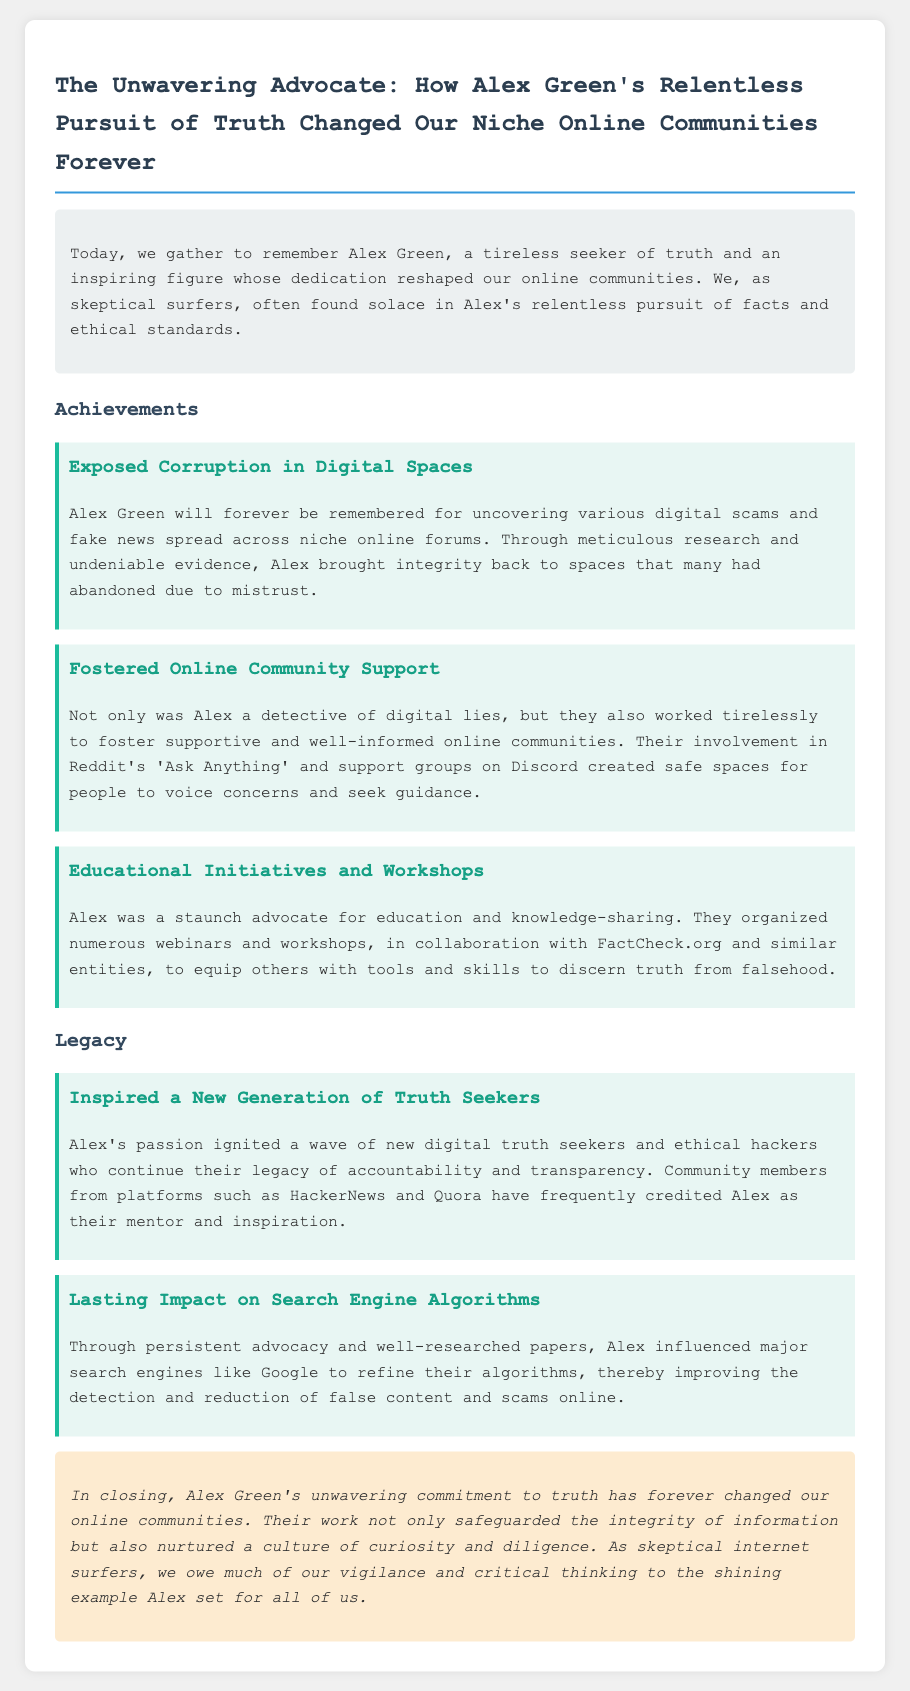What is the name of the deceased? The document specifically mentions the name of the deceased as Alex Green.
Answer: Alex Green What is one of Alex Green's notable achievements? The document lists several achievements under a heading, one of which is "Exposed Corruption in Digital Spaces."
Answer: Exposed Corruption in Digital Spaces How did Alex Green foster community support? The document describes Alex's involvement in online spaces such as Reddit's 'Ask Anything' and support groups on Discord.
Answer: Supported Reddit's 'Ask Anything' and Discord What organizations did Alex collaborate with for educational initiatives? The document specifically states that Alex organized webinars and workshops in collaboration with FactCheck.org.
Answer: FactCheck.org What impact did Alex have on search engine algorithms? The eulogy mentions that Alex influenced major search engines to improve detection and reduction of false content.
Answer: Improved detection of false content Who credited Alex as their mentor? The document notes that community members from platforms like HackerNews and Quora have frequently credited Alex.
Answer: HackerNews and Quora What kind of culture did Alex Green nurture in online communities? The conclusion of the document describes the culture that Alex nurtured as one of curiosity and diligence.
Answer: Curiosity and diligence What was a significant outcome of Alex's relentless pursuit of truth? The eulogy states that Alex's commitment has changed online communities forever, particularly regarding information integrity.
Answer: Changed online communities forever 